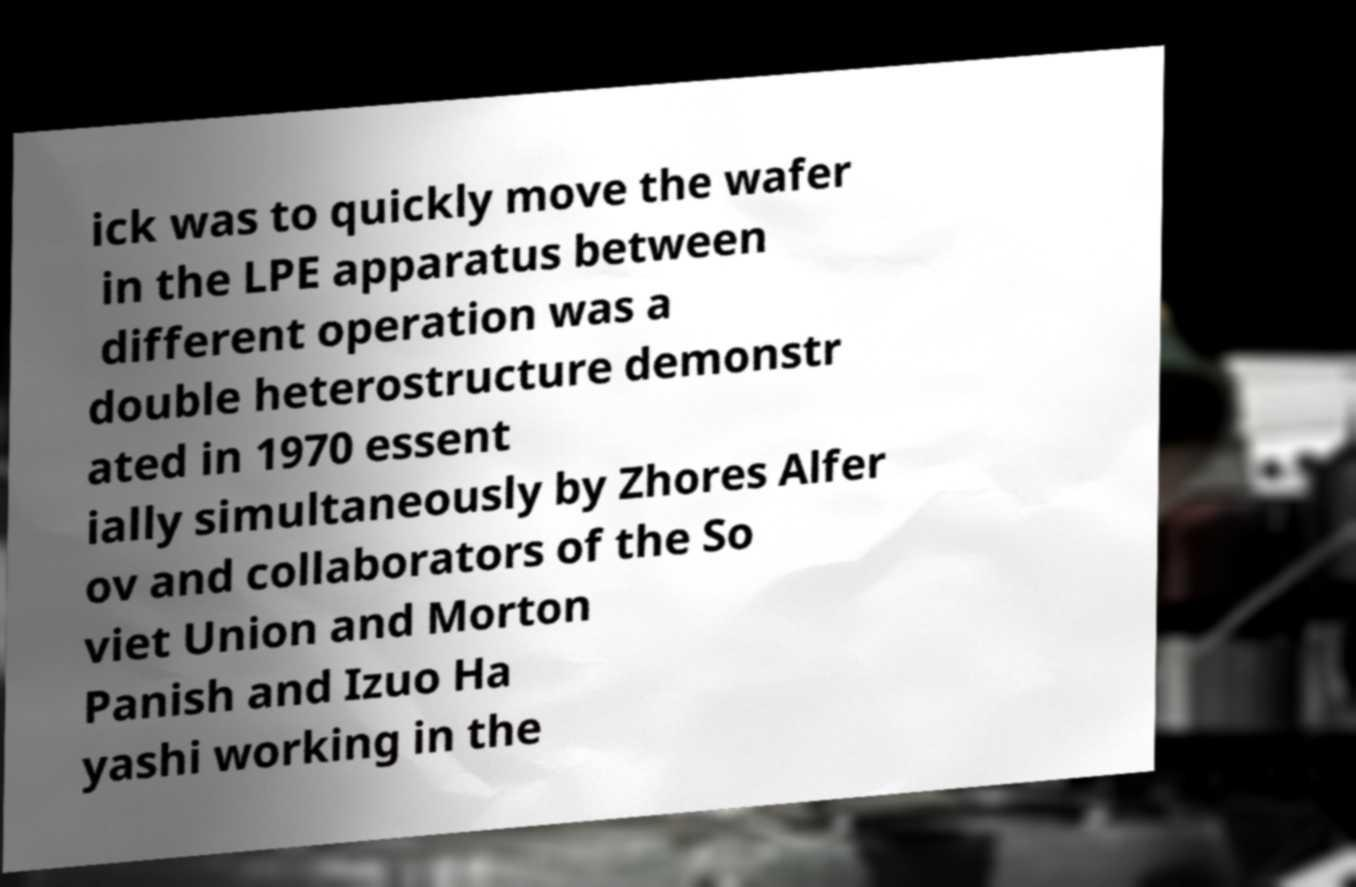I need the written content from this picture converted into text. Can you do that? ick was to quickly move the wafer in the LPE apparatus between different operation was a double heterostructure demonstr ated in 1970 essent ially simultaneously by Zhores Alfer ov and collaborators of the So viet Union and Morton Panish and Izuo Ha yashi working in the 